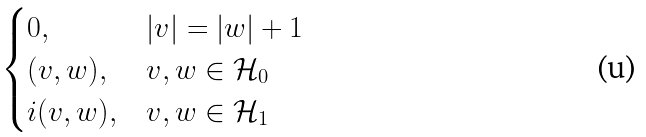Convert formula to latex. <formula><loc_0><loc_0><loc_500><loc_500>\begin{cases} 0 , & | v | = | w | + 1 \\ ( v , w ) , & v , w \in \mathcal { H } _ { 0 } \\ i ( v , w ) , & v , w \in \mathcal { H } _ { 1 } \end{cases}</formula> 